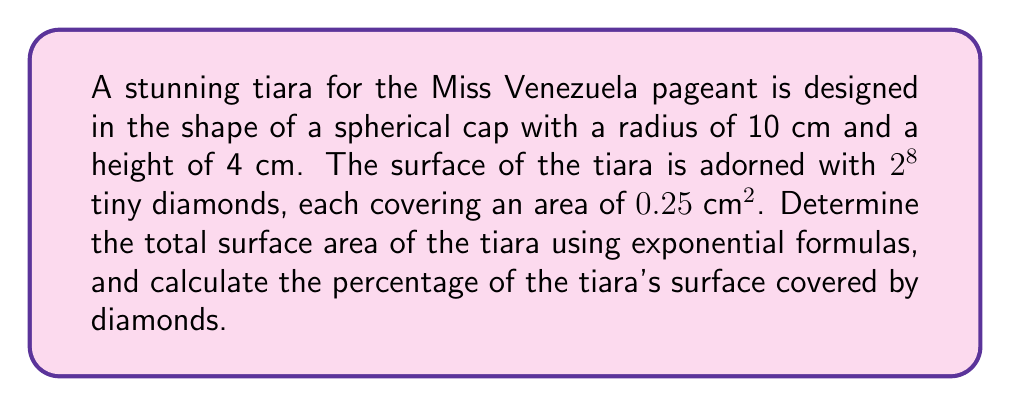Provide a solution to this math problem. Let's approach this step-by-step:

1) The surface area of a spherical cap is given by the formula:
   $$A = 2\pi rh$$
   where $r$ is the radius of the sphere and $h$ is the height of the cap.

2) Given: $r = 10$ cm, $h = 4$ cm
   Substituting these values:
   $$A = 2\pi (10)(4) = 80\pi \text{ cm}^2$$

3) Now, let's calculate the area covered by diamonds:
   Number of diamonds = $2^8 = 256$
   Area of each diamond = $0.25 \text{ cm}^2$
   
   Total area covered by diamonds:
   $$A_d = 256 \times 0.25 = 64 \text{ cm}^2$$

4) To calculate the percentage of the tiara's surface covered by diamonds:
   $$\text{Percentage} = \frac{A_d}{A} \times 100\% = \frac{64}{80\pi} \times 100\% \approx 25.46\%$$

5) Therefore, the total surface area of the tiara is $80\pi \text{ cm}^2$, and approximately 25.46% of its surface is covered by diamonds.
Answer: $80\pi \text{ cm}^2$; 25.46% 